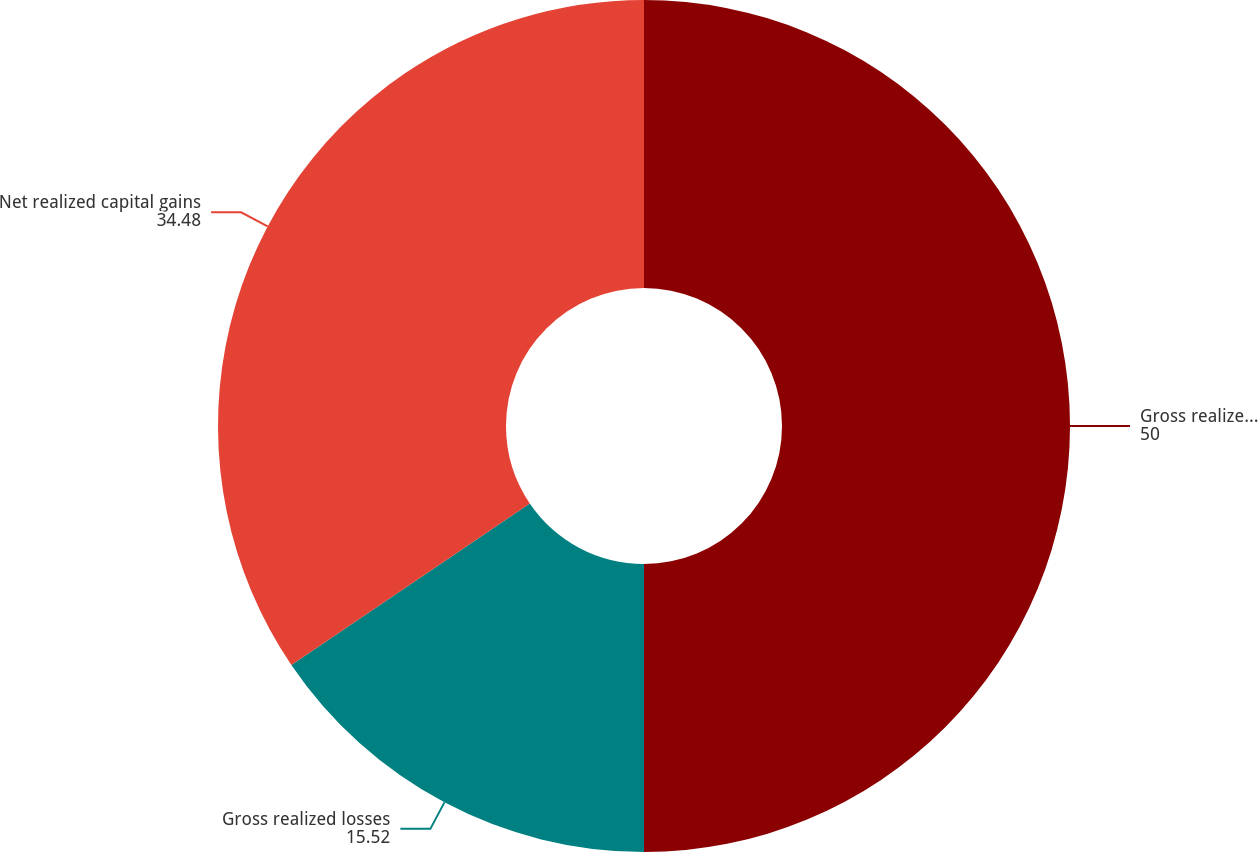Convert chart. <chart><loc_0><loc_0><loc_500><loc_500><pie_chart><fcel>Gross realized gains<fcel>Gross realized losses<fcel>Net realized capital gains<nl><fcel>50.0%<fcel>15.52%<fcel>34.48%<nl></chart> 